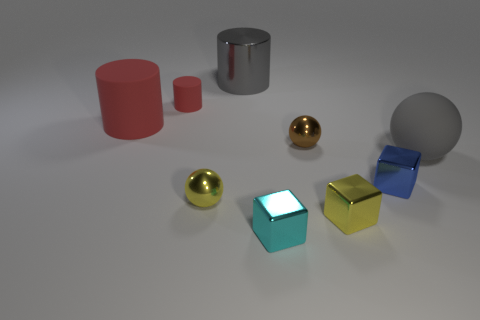Is there a big shiny object that has the same color as the small matte object? no 